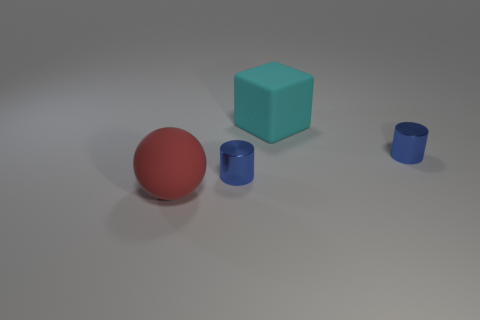Add 2 purple shiny blocks. How many objects exist? 6 Subtract all spheres. How many objects are left? 3 Add 4 blue metal things. How many blue metal things are left? 6 Add 2 tiny blue objects. How many tiny blue objects exist? 4 Subtract 0 brown cylinders. How many objects are left? 4 Subtract all brown spheres. Subtract all brown cylinders. How many spheres are left? 1 Subtract all yellow metallic cubes. Subtract all balls. How many objects are left? 3 